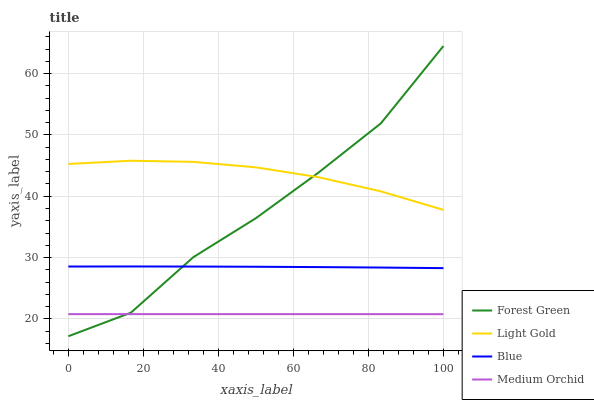Does Medium Orchid have the minimum area under the curve?
Answer yes or no. Yes. Does Light Gold have the maximum area under the curve?
Answer yes or no. Yes. Does Forest Green have the minimum area under the curve?
Answer yes or no. No. Does Forest Green have the maximum area under the curve?
Answer yes or no. No. Is Medium Orchid the smoothest?
Answer yes or no. Yes. Is Forest Green the roughest?
Answer yes or no. Yes. Is Forest Green the smoothest?
Answer yes or no. No. Is Medium Orchid the roughest?
Answer yes or no. No. Does Forest Green have the lowest value?
Answer yes or no. Yes. Does Medium Orchid have the lowest value?
Answer yes or no. No. Does Forest Green have the highest value?
Answer yes or no. Yes. Does Medium Orchid have the highest value?
Answer yes or no. No. Is Blue less than Light Gold?
Answer yes or no. Yes. Is Light Gold greater than Medium Orchid?
Answer yes or no. Yes. Does Forest Green intersect Medium Orchid?
Answer yes or no. Yes. Is Forest Green less than Medium Orchid?
Answer yes or no. No. Is Forest Green greater than Medium Orchid?
Answer yes or no. No. Does Blue intersect Light Gold?
Answer yes or no. No. 